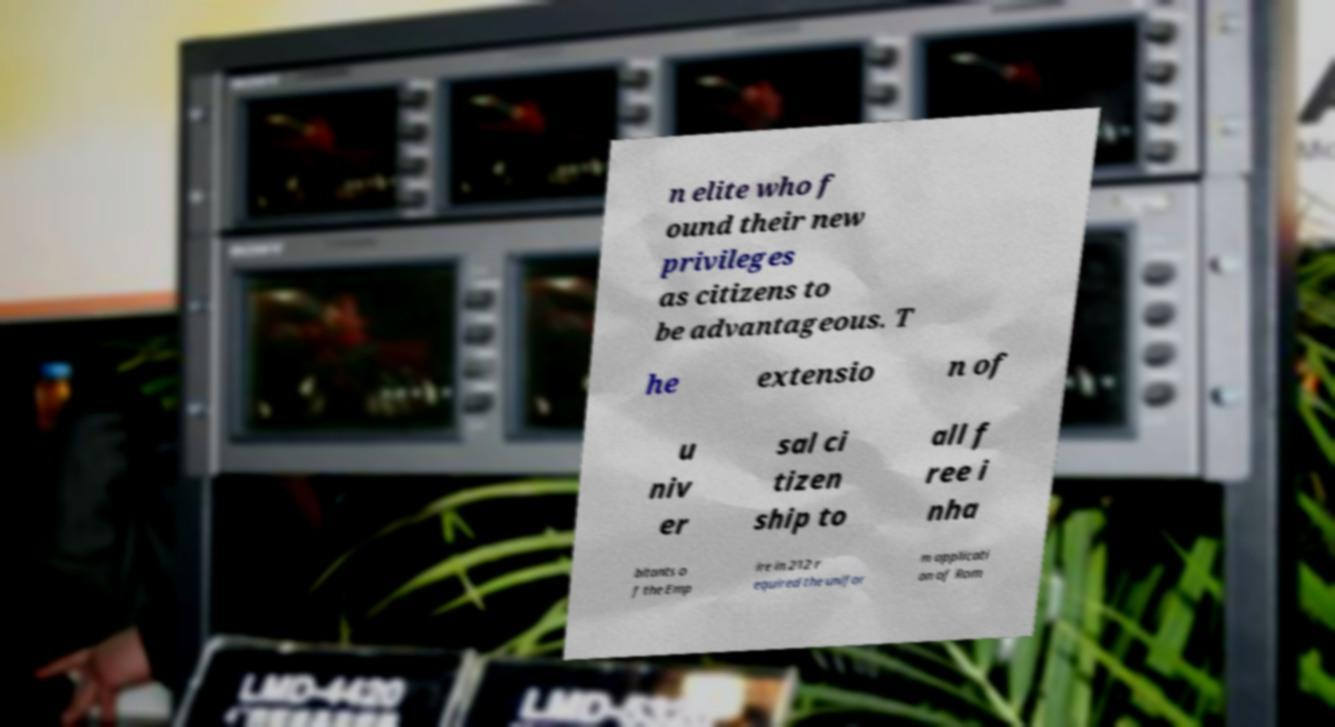Can you accurately transcribe the text from the provided image for me? n elite who f ound their new privileges as citizens to be advantageous. T he extensio n of u niv er sal ci tizen ship to all f ree i nha bitants o f the Emp ire in 212 r equired the unifor m applicati on of Rom 